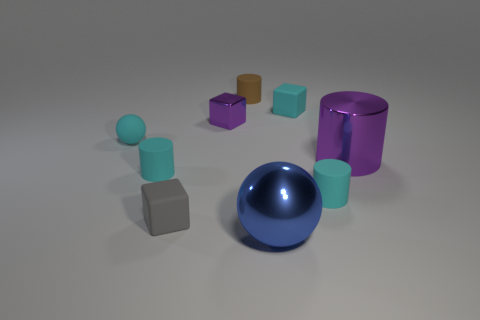What color is the matte object that is both behind the cyan rubber sphere and on the right side of the large blue metallic thing? The matte object located behind the cyan rubber sphere and to the right of the large blue metallic object is gray. 